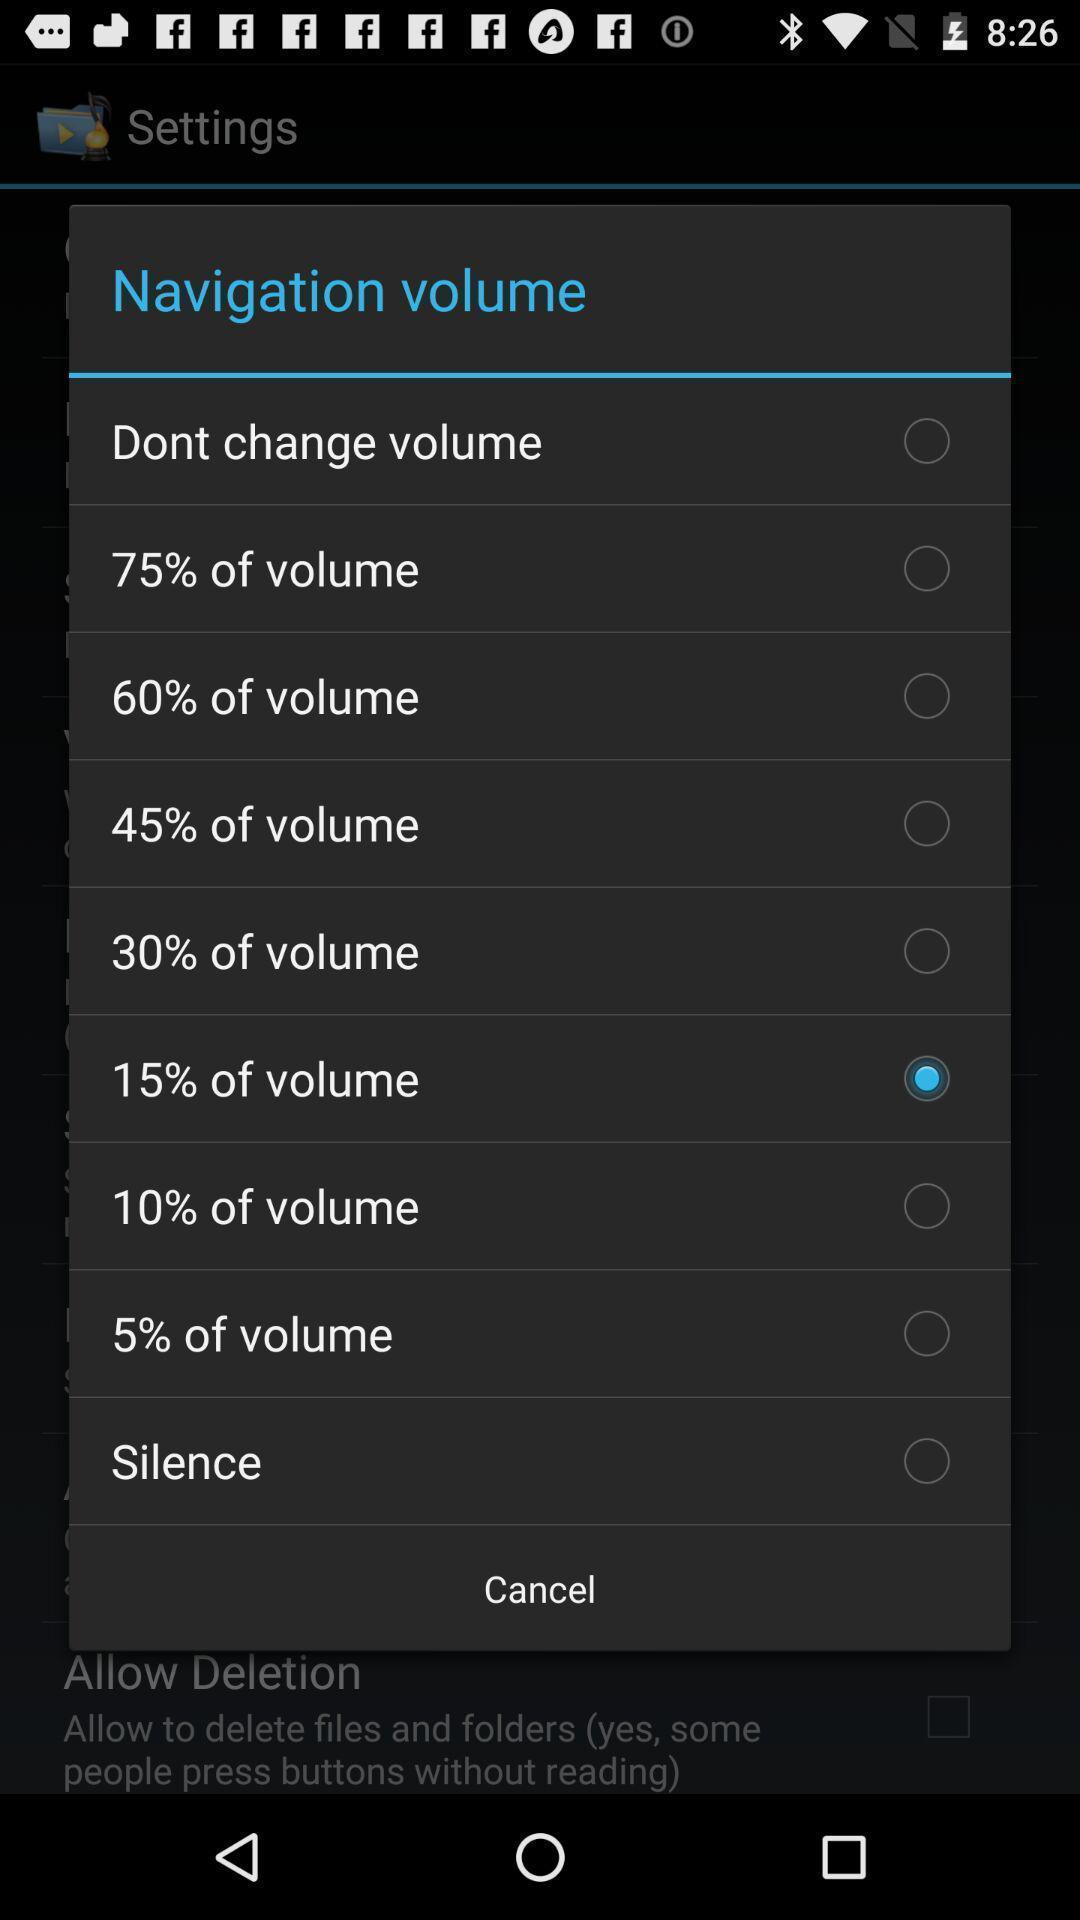Provide a detailed account of this screenshot. Popup showing volume options. 